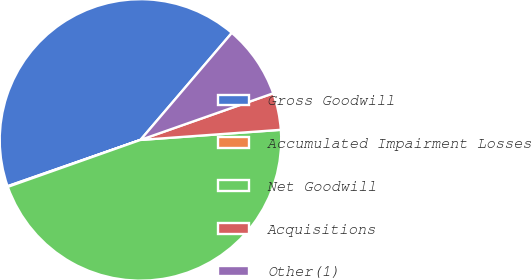<chart> <loc_0><loc_0><loc_500><loc_500><pie_chart><fcel>Gross Goodwill<fcel>Accumulated Impairment Losses<fcel>Net Goodwill<fcel>Acquisitions<fcel>Other(1)<nl><fcel>41.58%<fcel>0.08%<fcel>45.73%<fcel>4.23%<fcel>8.38%<nl></chart> 